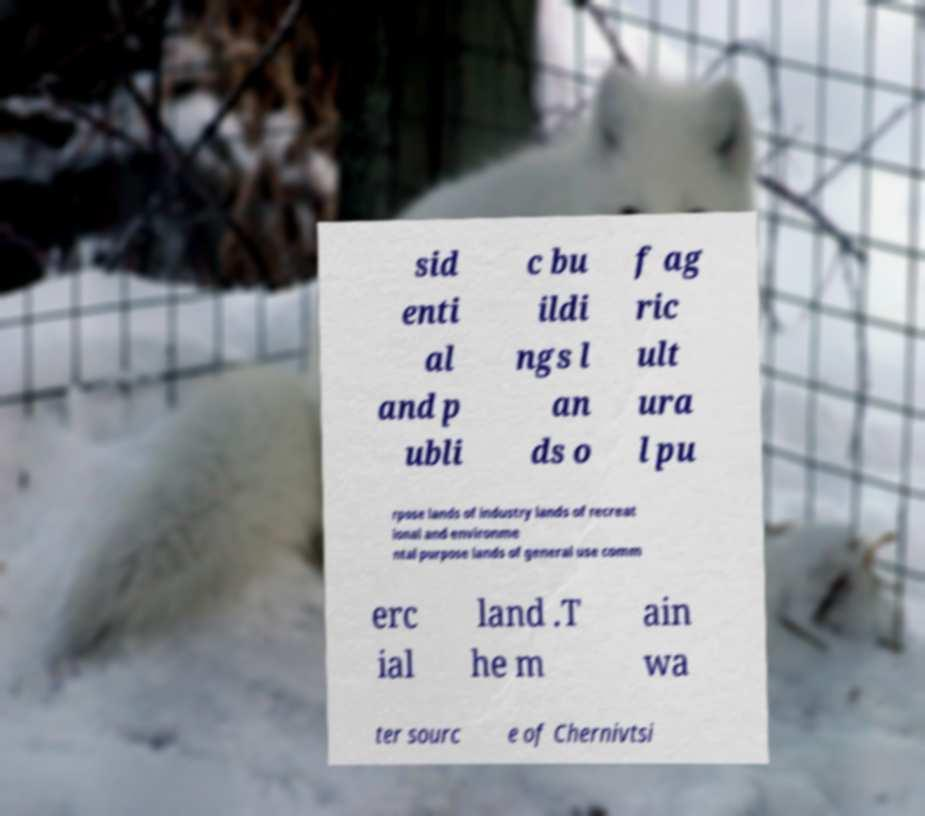There's text embedded in this image that I need extracted. Can you transcribe it verbatim? sid enti al and p ubli c bu ildi ngs l an ds o f ag ric ult ura l pu rpose lands of industry lands of recreat ional and environme ntal purpose lands of general use comm erc ial land .T he m ain wa ter sourc e of Chernivtsi 